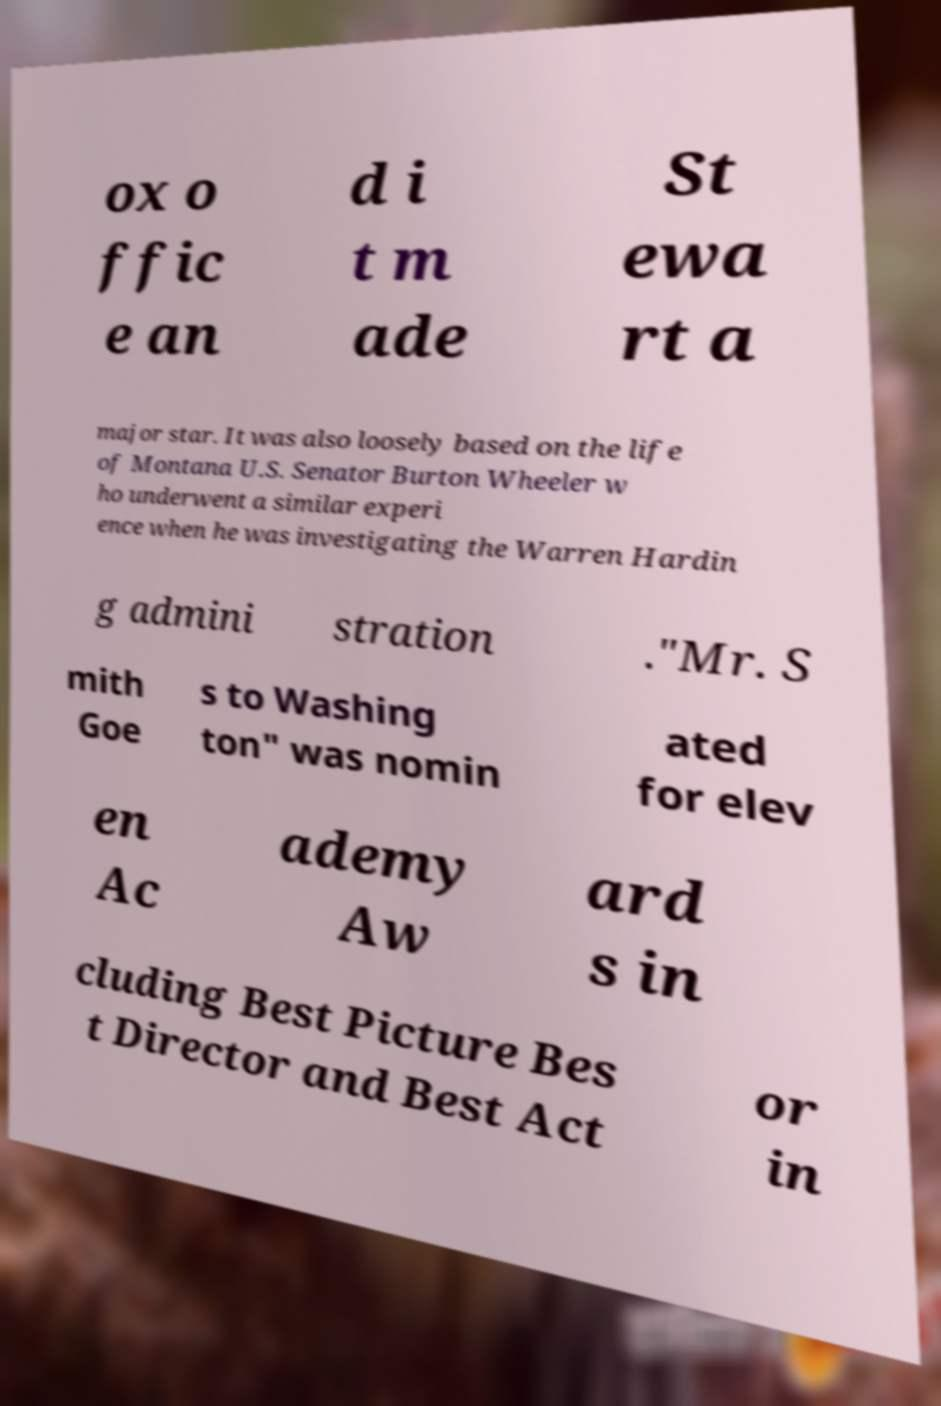Please identify and transcribe the text found in this image. ox o ffic e an d i t m ade St ewa rt a major star. It was also loosely based on the life of Montana U.S. Senator Burton Wheeler w ho underwent a similar experi ence when he was investigating the Warren Hardin g admini stration ."Mr. S mith Goe s to Washing ton" was nomin ated for elev en Ac ademy Aw ard s in cluding Best Picture Bes t Director and Best Act or in 